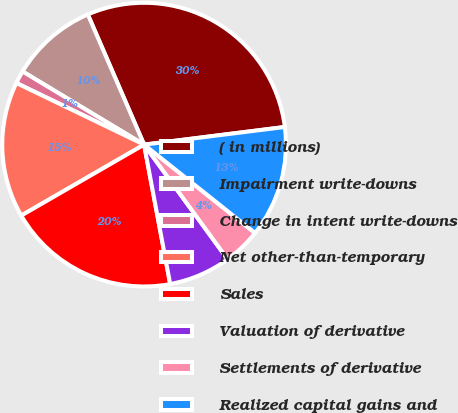<chart> <loc_0><loc_0><loc_500><loc_500><pie_chart><fcel>( in millions)<fcel>Impairment write-downs<fcel>Change in intent write-downs<fcel>Net other-than-temporary<fcel>Sales<fcel>Valuation of derivative<fcel>Settlements of derivative<fcel>Realized capital gains and<nl><fcel>29.51%<fcel>9.88%<fcel>1.47%<fcel>15.49%<fcel>19.61%<fcel>7.08%<fcel>4.27%<fcel>12.69%<nl></chart> 